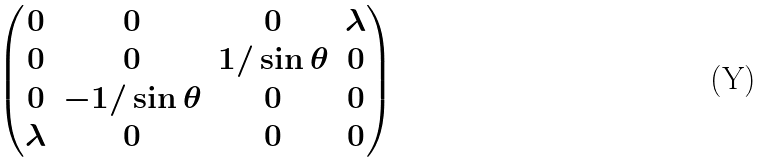Convert formula to latex. <formula><loc_0><loc_0><loc_500><loc_500>\begin{pmatrix} 0 & 0 & 0 & \lambda \\ 0 & 0 & 1 / \sin \theta & 0 \\ 0 & - 1 / \sin \theta & 0 & 0 \\ \lambda & 0 & 0 & 0 \end{pmatrix}</formula> 